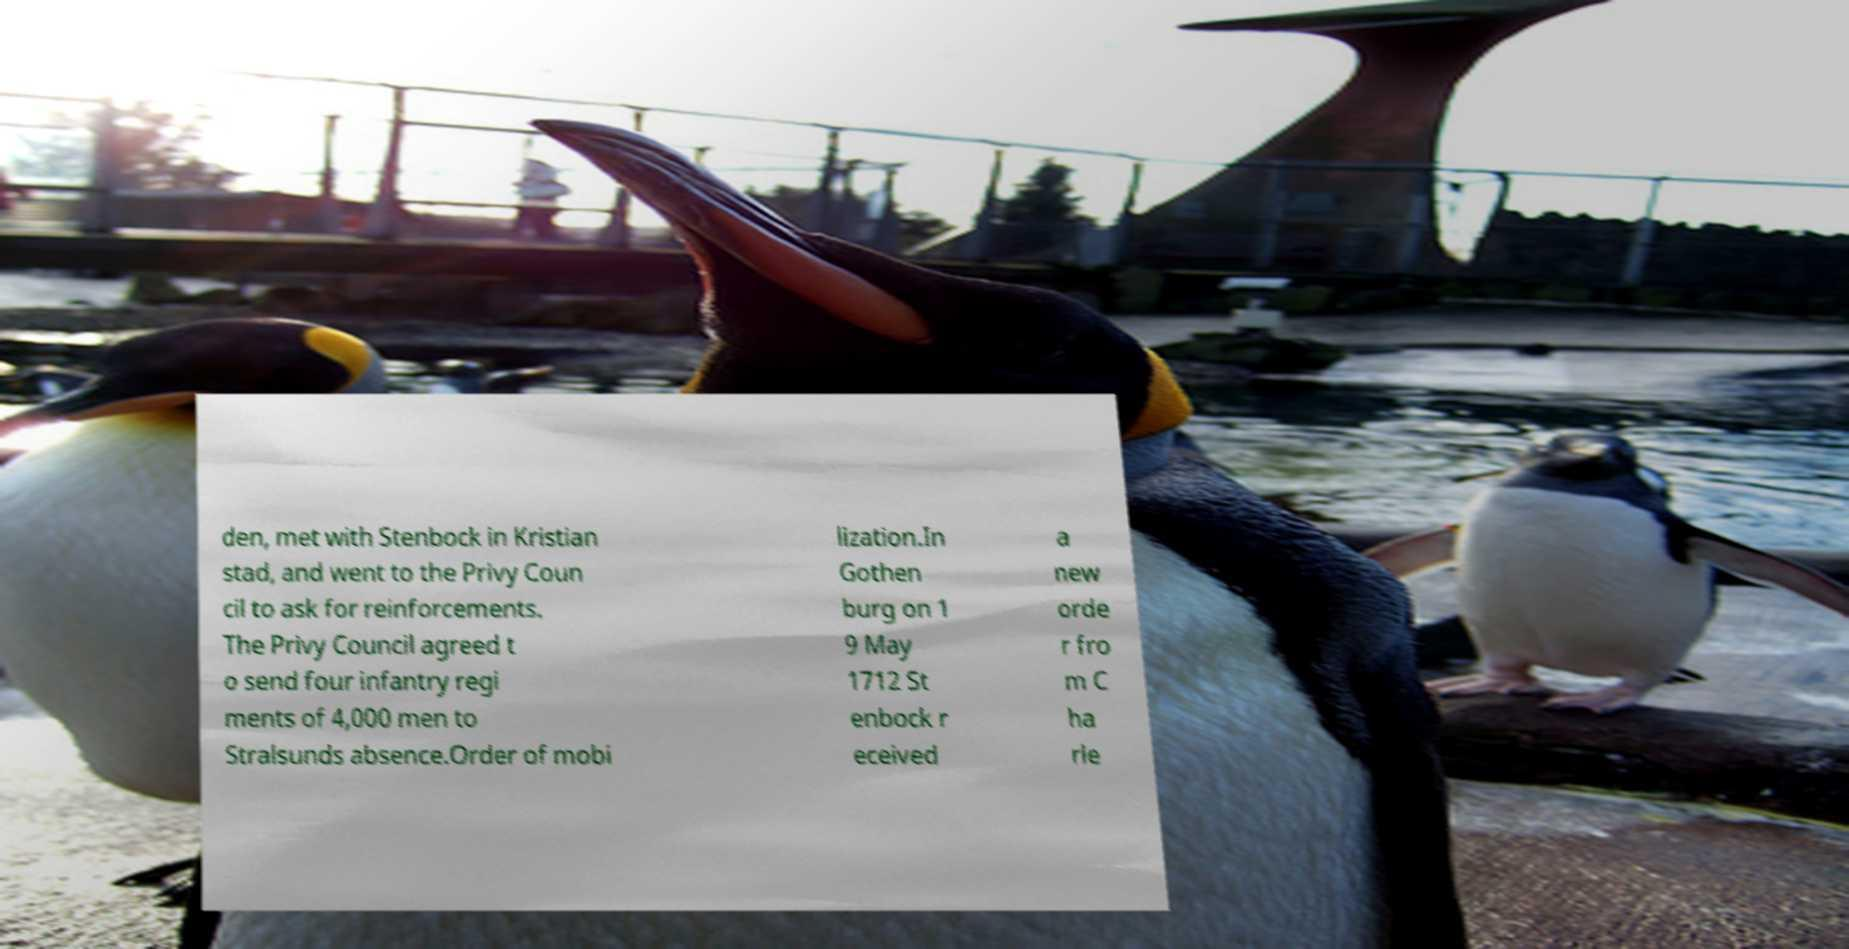Can you read and provide the text displayed in the image?This photo seems to have some interesting text. Can you extract and type it out for me? den, met with Stenbock in Kristian stad, and went to the Privy Coun cil to ask for reinforcements. The Privy Council agreed t o send four infantry regi ments of 4,000 men to Stralsunds absence.Order of mobi lization.In Gothen burg on 1 9 May 1712 St enbock r eceived a new orde r fro m C ha rle 